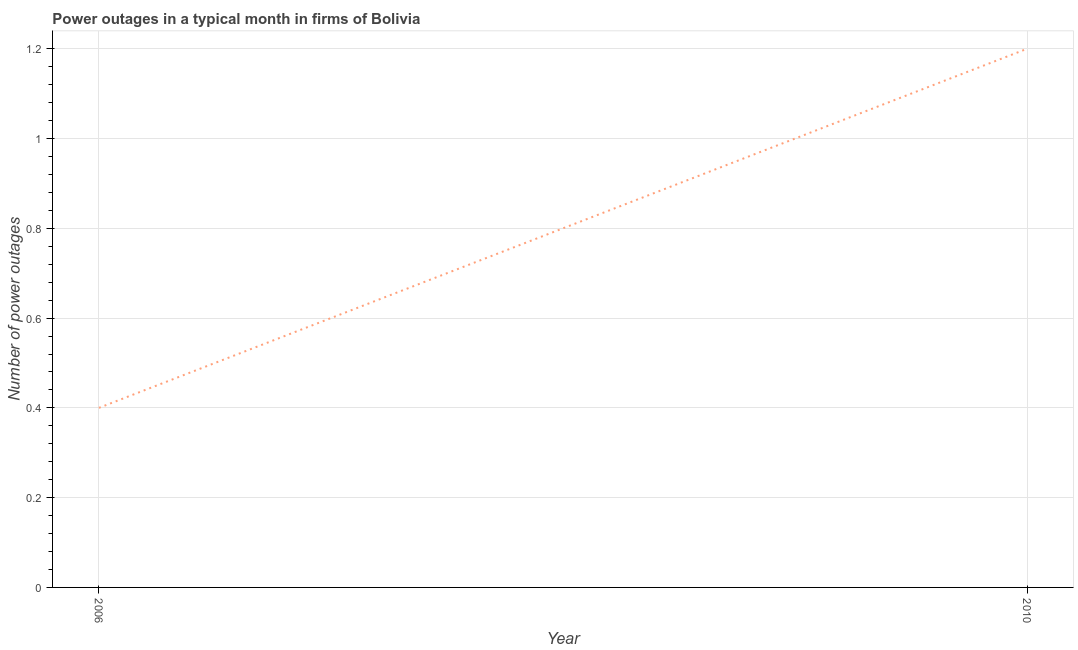What is the number of power outages in 2006?
Keep it short and to the point. 0.4. Across all years, what is the minimum number of power outages?
Provide a succinct answer. 0.4. What is the difference between the number of power outages in 2006 and 2010?
Keep it short and to the point. -0.8. What is the median number of power outages?
Your answer should be compact. 0.8. In how many years, is the number of power outages greater than 0.92 ?
Offer a very short reply. 1. What is the ratio of the number of power outages in 2006 to that in 2010?
Your answer should be very brief. 0.33. Is the number of power outages in 2006 less than that in 2010?
Give a very brief answer. Yes. Does the number of power outages monotonically increase over the years?
Keep it short and to the point. Yes. How many lines are there?
Offer a terse response. 1. How many years are there in the graph?
Keep it short and to the point. 2. Are the values on the major ticks of Y-axis written in scientific E-notation?
Give a very brief answer. No. Does the graph contain any zero values?
Ensure brevity in your answer.  No. Does the graph contain grids?
Offer a terse response. Yes. What is the title of the graph?
Make the answer very short. Power outages in a typical month in firms of Bolivia. What is the label or title of the Y-axis?
Offer a very short reply. Number of power outages. What is the Number of power outages of 2006?
Offer a very short reply. 0.4. What is the difference between the Number of power outages in 2006 and 2010?
Your answer should be very brief. -0.8. What is the ratio of the Number of power outages in 2006 to that in 2010?
Offer a terse response. 0.33. 